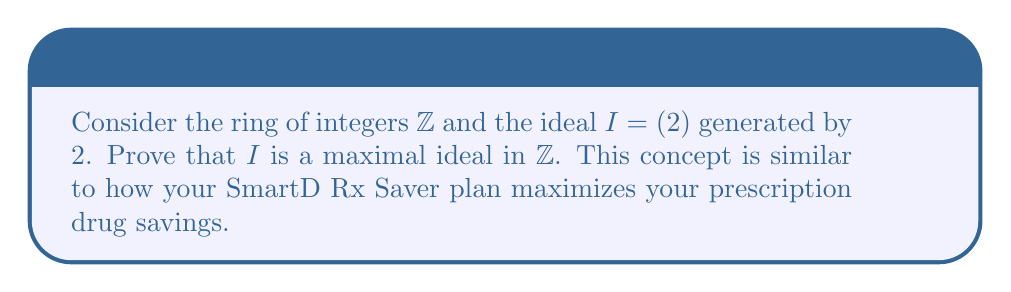Could you help me with this problem? Let's approach this step-by-step:

1) First, recall that an ideal $I$ in a ring $R$ is maximal if for any ideal $J$ such that $I \subseteq J \subseteq R$, either $J = I$ or $J = R$.

2) In our case, $R = \mathbb{Z}$ and $I = (2) = \{2n : n \in \mathbb{Z}\}$.

3) Let $J$ be an ideal in $\mathbb{Z}$ such that $I \subseteq J \subseteq \mathbb{Z}$.

4) Since $J$ contains $I$, it must contain 2. Let's consider an arbitrary element $a \in J$ that is not in $I$.

5) Since $a \notin I$, $a$ is odd. We can write $a = 2k + 1$ for some integer $k$.

6) Now, since $J$ is an ideal and contains both $a$ and 2, it must also contain their difference:
   $a - 2k = (2k + 1) - 2k = 1$

7) If $J$ contains 1, then it must contain all integers (since for any integer $n$, $n \cdot 1 = n$).

8) Therefore, if $J$ contains any element not in $I$, it must be equal to $\mathbb{Z}$.

9) This proves that there is no proper ideal strictly between $I$ and $\mathbb{Z}$.

Thus, $I = (2)$ is a maximal ideal in $\mathbb{Z}$.
Answer: $(2)$ is maximal in $\mathbb{Z}$ as any larger ideal equals $\mathbb{Z}$. 